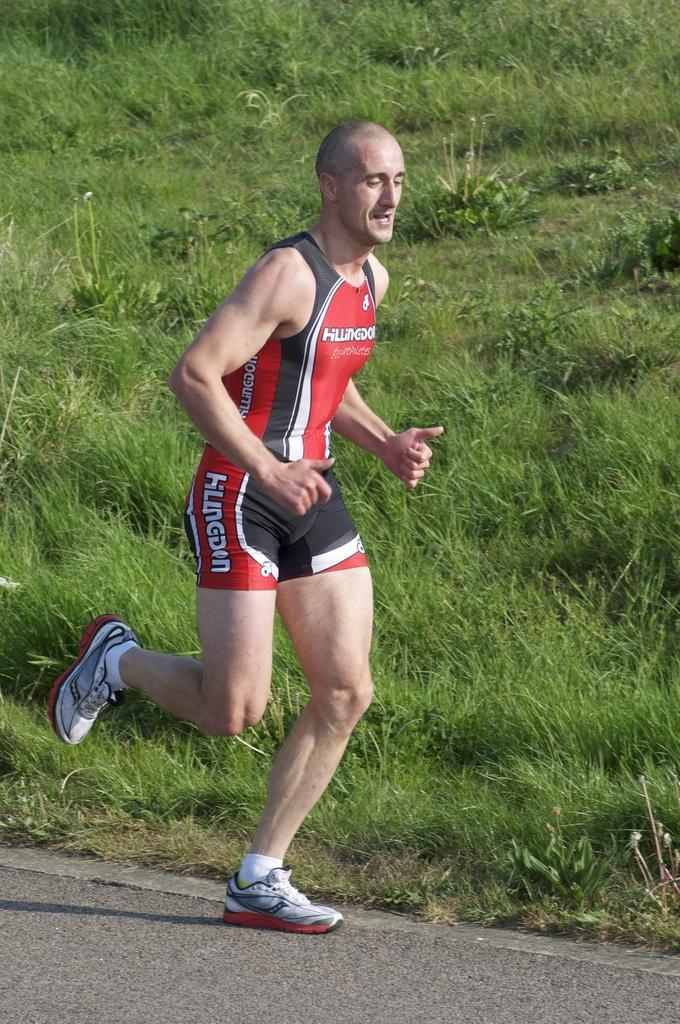<image>
Present a compact description of the photo's key features. A runner sports a colorful outfit with Hillingdon on it in several places. 